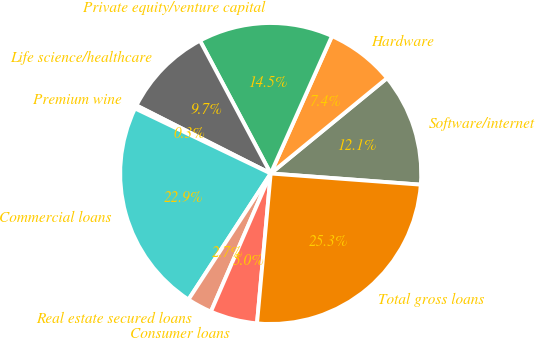<chart> <loc_0><loc_0><loc_500><loc_500><pie_chart><fcel>Software/internet<fcel>Hardware<fcel>Private equity/venture capital<fcel>Life science/healthcare<fcel>Premium wine<fcel>Commercial loans<fcel>Real estate secured loans<fcel>Consumer loans<fcel>Total gross loans<nl><fcel>12.11%<fcel>7.4%<fcel>14.46%<fcel>9.75%<fcel>0.35%<fcel>22.92%<fcel>2.7%<fcel>5.05%<fcel>25.27%<nl></chart> 